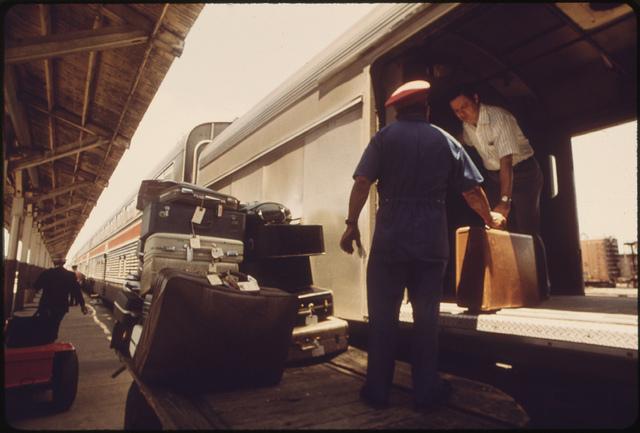What color are the luggages?
Be succinct. Black and silver. Are these men working?
Short answer required. Yes. What are the men doing with the luggage?
Be succinct. Unloading. How many red cases are there?
Write a very short answer. 1. Are they actors?
Give a very brief answer. No. Is this an airplane?
Write a very short answer. No. How many luggage are stacked in the picture?
Concise answer only. 10. 